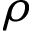Convert formula to latex. <formula><loc_0><loc_0><loc_500><loc_500>\rho</formula> 